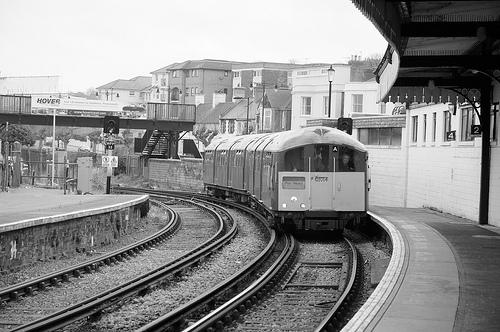What type of train is on the tracks, and what is beneath it? It is a passenger train on the tracks, and there are steel tracks and gravel underneath it. Briefly explain what the advertisements with the letters "h, o, v, e, r" are doing in the image. The advertisements with the letters "h, o, v, e, r" are forming the word "hover" at different positions in the image. Count the sets of train tracks in the image, and describe their current usage. There are two sets of parallel train tracks. One set is in use by the train, and the other set is not in use. Analyzing the image, what is the emotion or feeling it evokes? The image evokes a sense of motion and anticipation as the passenger train arrives at the station. Explain the purpose of the line painted along the side of the train tracks in the image. The line might indicate a boundary or safety margin for platform users. Based on the image, determine whether the train tracks are positioned in parallel or crossed in a different manner. There are two sets of parallel train tracks. What features of the train are most prominent in the image? Windows, wheels, and lights on the train. How many train platforms are visible in the image, and on which side of the tracks are they located? Two train platforms, one on the left side and one on the right side. Is the train on a straight or curved section of the tracks? The train is on a curved section of the tracks. In the image, determine which side of the tracks the houses are located. Houses are on the right side. Identify which type of lights are present in the image. Street lights with lamps What letters are advertised in the image and describe their purpose. Letters h, o, v, e, r are part of an advertisement. Identify any structures that are covering the train platform. Shelter over train platform. What numbers are seen on information signs in the image? 2 and 4 Describe the type of buildings observed in the background of the image. Houses and buildings with multiple windows are present in the background. Write a caption that includes the train, the train tracks, and the street lights. A picturesque scene featuring a 6 car passenger train gracefully turning a corner on curved train tracks, with street lights illuminating in the background. Analyze the image and make a list of materials that are found beneath the train. Steel tracks, gravel, and ground. List the types of rail infrastructure visible in the image. Bridge over the train tracks, street lights with lamps, steel rails, and tall lamp post. In the image, determine whether the train is arriving or departing the station. The train is coming into the station. What is the state of the train tracks not in use? The unused train tracks are parallel and possibly in need of some maintenance. What type of train is depicted in the image? 6 car passenger train Does the image show an awning, and if so, where is it located? Yes, there is an awning over the track and station. Describe the windows seen on the buildings in the image. Multiple windows on the houses and buildings in the background. 